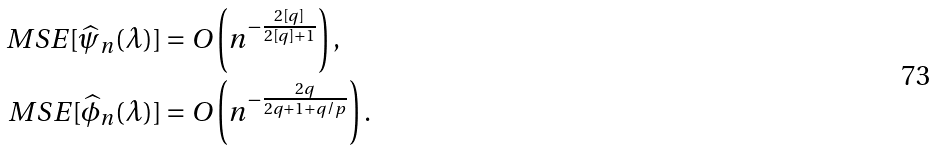Convert formula to latex. <formula><loc_0><loc_0><loc_500><loc_500>M S E [ \widehat { \psi } _ { n } ( \lambda ) ] & = O \left ( n ^ { - \frac { 2 [ q ] } { 2 [ q ] + 1 } } \right ) , \\ M S E [ \widehat { \phi } _ { n } ( \lambda ) ] & = O \left ( n ^ { - \frac { 2 q } { 2 q + 1 + q / p } } \right ) .</formula> 